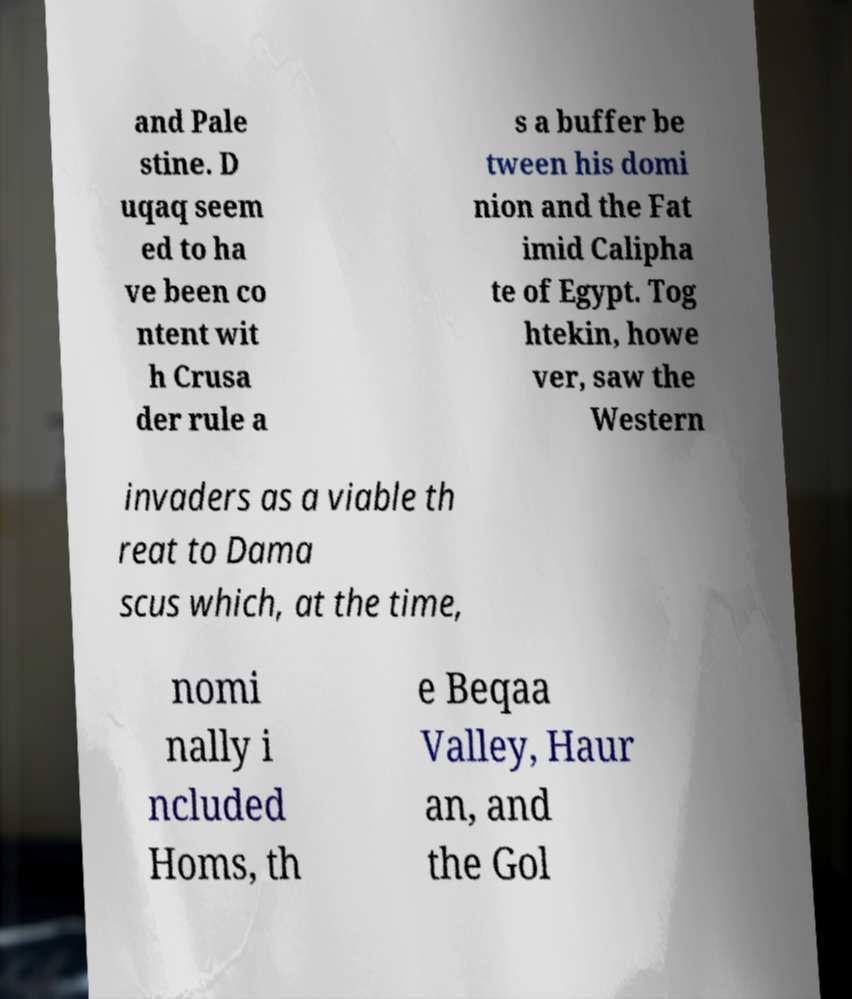Could you extract and type out the text from this image? and Pale stine. D uqaq seem ed to ha ve been co ntent wit h Crusa der rule a s a buffer be tween his domi nion and the Fat imid Calipha te of Egypt. Tog htekin, howe ver, saw the Western invaders as a viable th reat to Dama scus which, at the time, nomi nally i ncluded Homs, th e Beqaa Valley, Haur an, and the Gol 